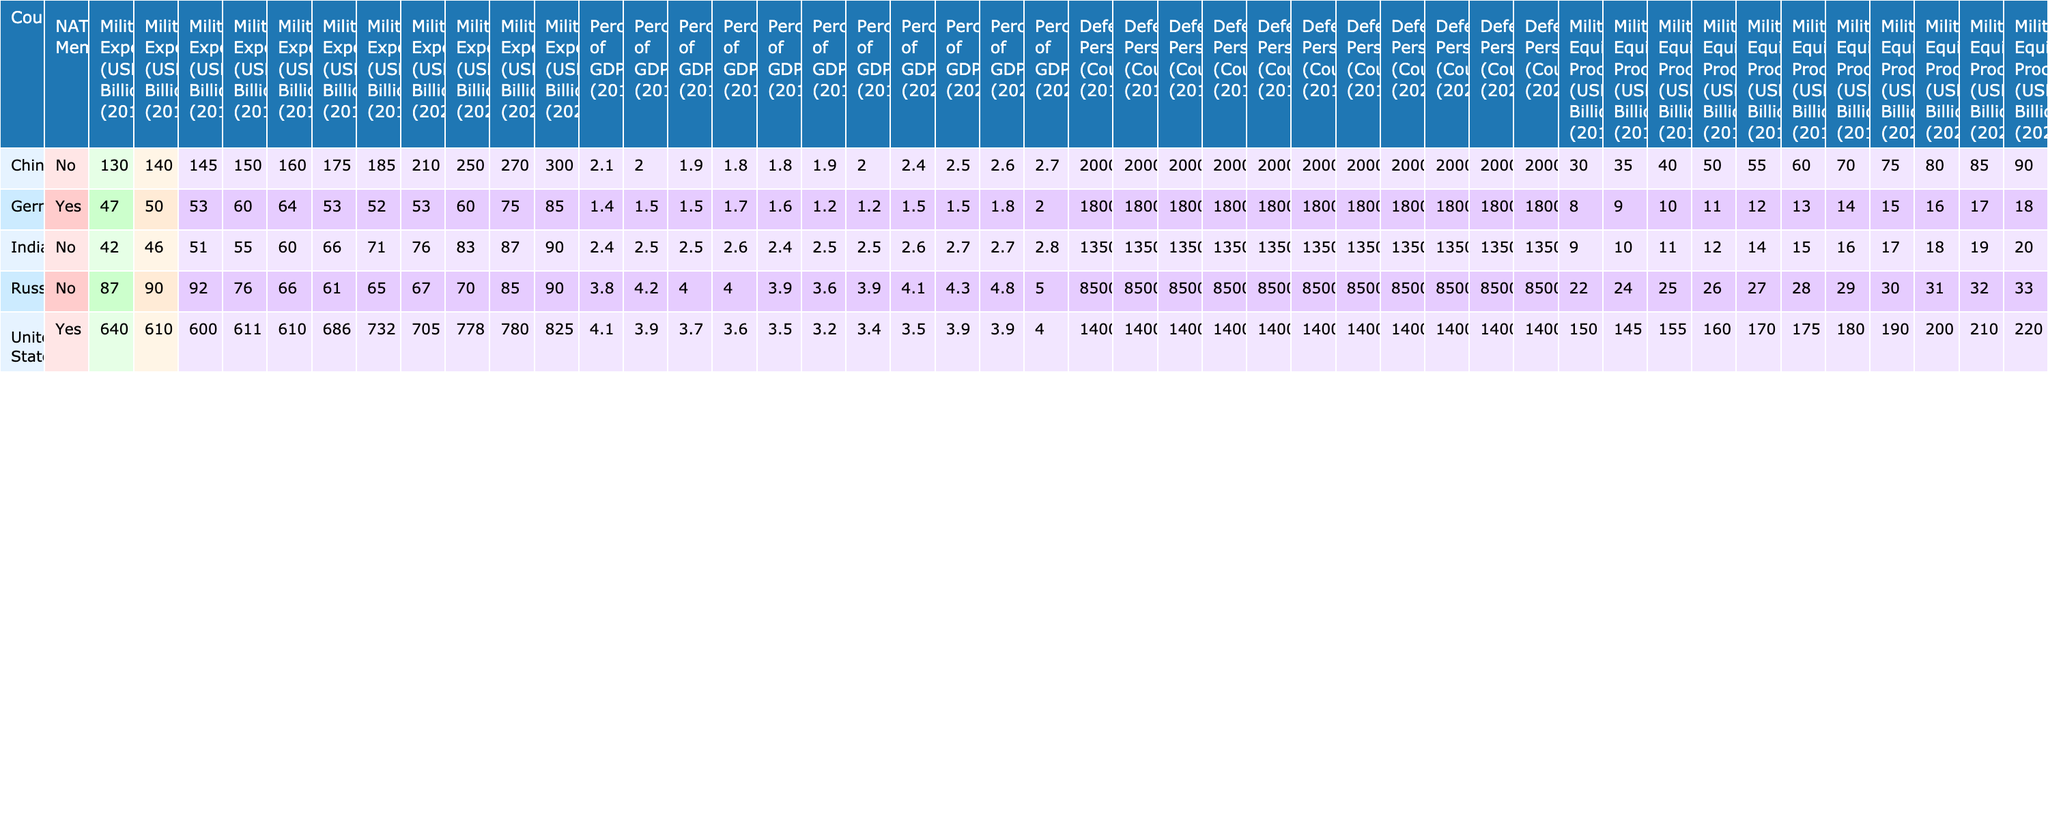What was the highest military expenditure recorded among NATO members in 2023? The table indicates that the United States had the highest military expenditure among NATO members in 2023, with an amount of 825 billion USD.
Answer: 825 billion USD Which country had the lowest military expenditure in 2013? In 2013, Germany had the lowest military expenditure among the countries listed, with an expenditure of 47 billion USD.
Answer: 47 billion USD What was the percentage of GDP for Russia's military expenditure in 2018? According to the table, Russia's military expenditure as a percentage of GDP in 2018 was 3.6%.
Answer: 3.6% How much did China's military expenditure increase from 2013 to 2023? China's military expenditure in 2013 was 130 billion USD and in 2023 it was 300 billion USD. The increase is calculated as 300 - 130 = 170 billion USD.
Answer: 170 billion USD Did Germany's military expenditure exceed 75 billion USD in 2022? The table shows that Germany's military expenditure in 2022 was 75 billion USD, which means it did not exceed 75 billion USD.
Answer: No What was the average military expenditure for India over the past decade? To calculate the average, sum India's military expenditures from 2013 to 2023: (42 + 46 + 51 + 55 + 60 + 66 + 71 + 76 + 83 + 87 + 90) =  800 billion USD. Dividing by 11 (the total number of years) gives an average of approximately 72.73 billion USD.
Answer: Approximately 72.73 billion USD Which NATO member had the highest percentage of GDP spent on military expenditure in 2022? In 2022, Germany had the highest percentage of GDP spent on military expenditure among NATO members with 1.8%.
Answer: 1.8% How did the military personnel count of the United States compare to that of China in 2021? In 2021, the United States had 1,400,000 defense personnel while China had 2,000,000. Therefore, China had more defense personnel than the United States in that year.
Answer: China had more personnel What was the trend in military expenditure for Russia from 2013 to 2023? Reviewing the data from 2013 (87 billion USD) to 2023 (90 billion USD), Russia's military expenditure shows an overall increase over the decade, with fluctuations, culminating in a rise of 3 billion USD from the initial year.
Answer: Overall increase In which year did Germany first exceed a military expenditure of 60 billion USD? Germany first exceeded a military expenditure of 60 billion USD in 2022 (75 billion USD).
Answer: 2022 What was the total military expenditure for the United States over the last decade? The total of the United States military expenditures from 2013 to 2023 is calculated as: 640 + 610 + 600 + 611 + 610 + 686 + 732 + 705 + 778 + 780 + 825 =  8,391 billion USD.
Answer: 8,391 billion USD 